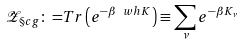<formula> <loc_0><loc_0><loc_500><loc_500>\mathcal { Z } _ { \S c g } { \colon = } T r \left ( e ^ { - \beta \ w h { K } } \right ) \equiv \sum _ { \nu } e ^ { - \beta K _ { \nu } }</formula> 